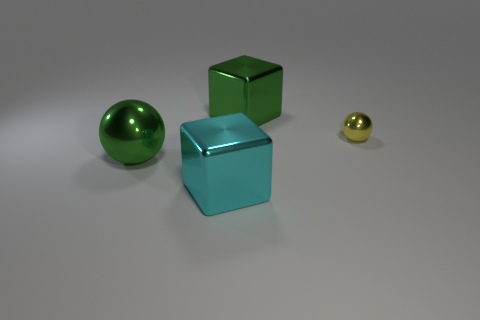Add 2 big green metal things. How many objects exist? 6 Subtract all cyan cubes. How many cubes are left? 1 Add 3 large blocks. How many large blocks exist? 5 Subtract 0 brown cubes. How many objects are left? 4 Subtract 2 balls. How many balls are left? 0 Subtract all green blocks. Subtract all purple balls. How many blocks are left? 1 Subtract all gray balls. How many cyan blocks are left? 1 Subtract all large metal balls. Subtract all big blue cubes. How many objects are left? 3 Add 2 shiny objects. How many shiny objects are left? 6 